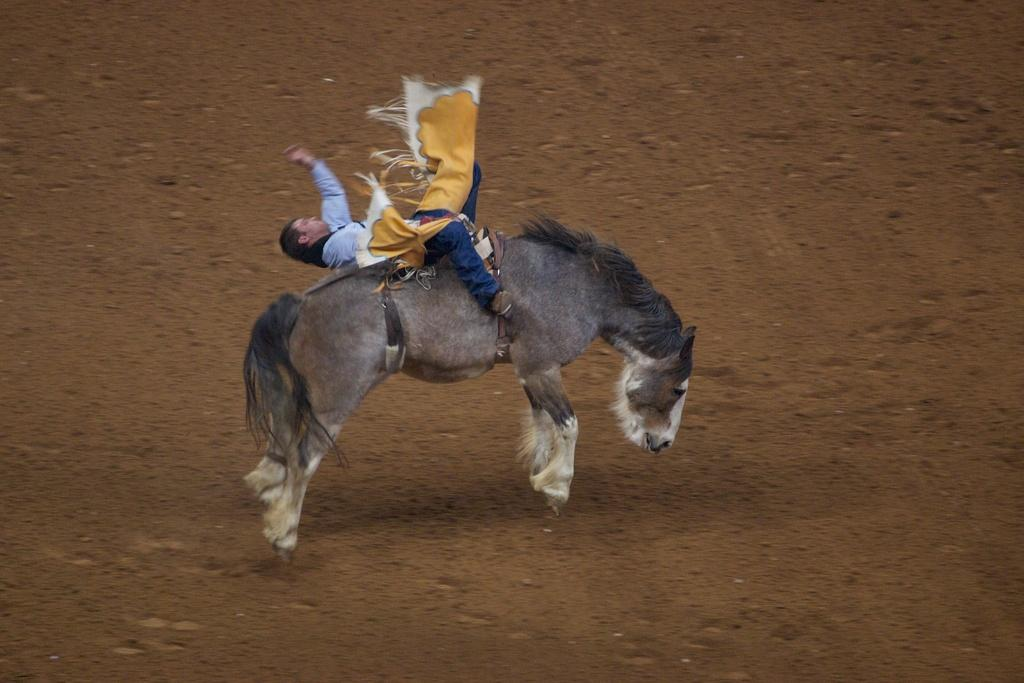Who or what is the main subject in the image? There is a person in the image. What is the person doing in the image? The person is riding a horse. Where are the horse and rider located in the image? The horse and rider are on the ground. What type of thunder can be heard in the image? There is no thunder present in the image, as it is a visual representation and does not include sound. 